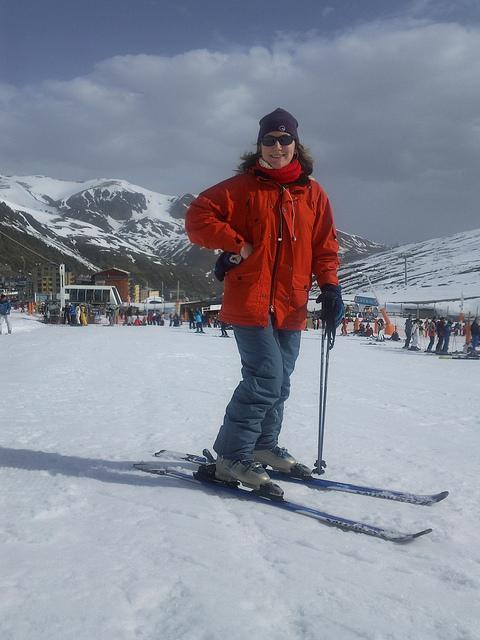How many people are there?
Give a very brief answer. 2. 